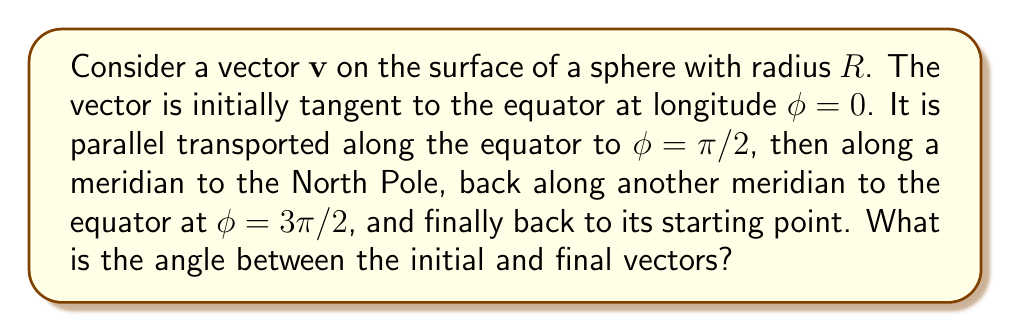What is the answer to this math problem? Let's approach this step-by-step:

1) Parallel transport preserves the angle between the vector and the curve it's being transported along. On a flat surface, the vector would return to its original orientation after a closed loop.

2) However, on a curved surface like a sphere, the vector's orientation can change due to the curvature. This change is called holonomy.

3) For a sphere, the holonomy is related to the solid angle enclosed by the path. The solid angle of a spherical triangle is given by:

   $$\Omega = \alpha + \beta + \gamma - \pi$$

   where $\alpha$, $\beta$, and $\gamma$ are the angles of the spherical triangle.

4) In our case, the path forms a spherical triangle with three right angles (π/2 each). So:

   $$\Omega = \frac{\pi}{2} + \frac{\pi}{2} + \frac{\pi}{2} - \pi = \frac{\pi}{2}$$

5) The holonomy angle θ (the angle between the initial and final vectors) is related to the solid angle by:

   $$\theta = \Omega = \frac{\pi}{2}$$

6) Therefore, after parallel transport around this closed path on the sphere, the vector will have rotated by π/2 radians or 90 degrees relative to its initial orientation.
Answer: $\frac{\pi}{2}$ radians or 90° 